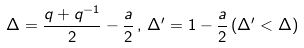Convert formula to latex. <formula><loc_0><loc_0><loc_500><loc_500>\Delta = \frac { q + q ^ { - 1 } } { 2 } - \frac { a } { 2 } \, , \, \Delta ^ { \prime } = 1 - \frac { a } { 2 } \, ( \Delta ^ { \prime } < \Delta )</formula> 